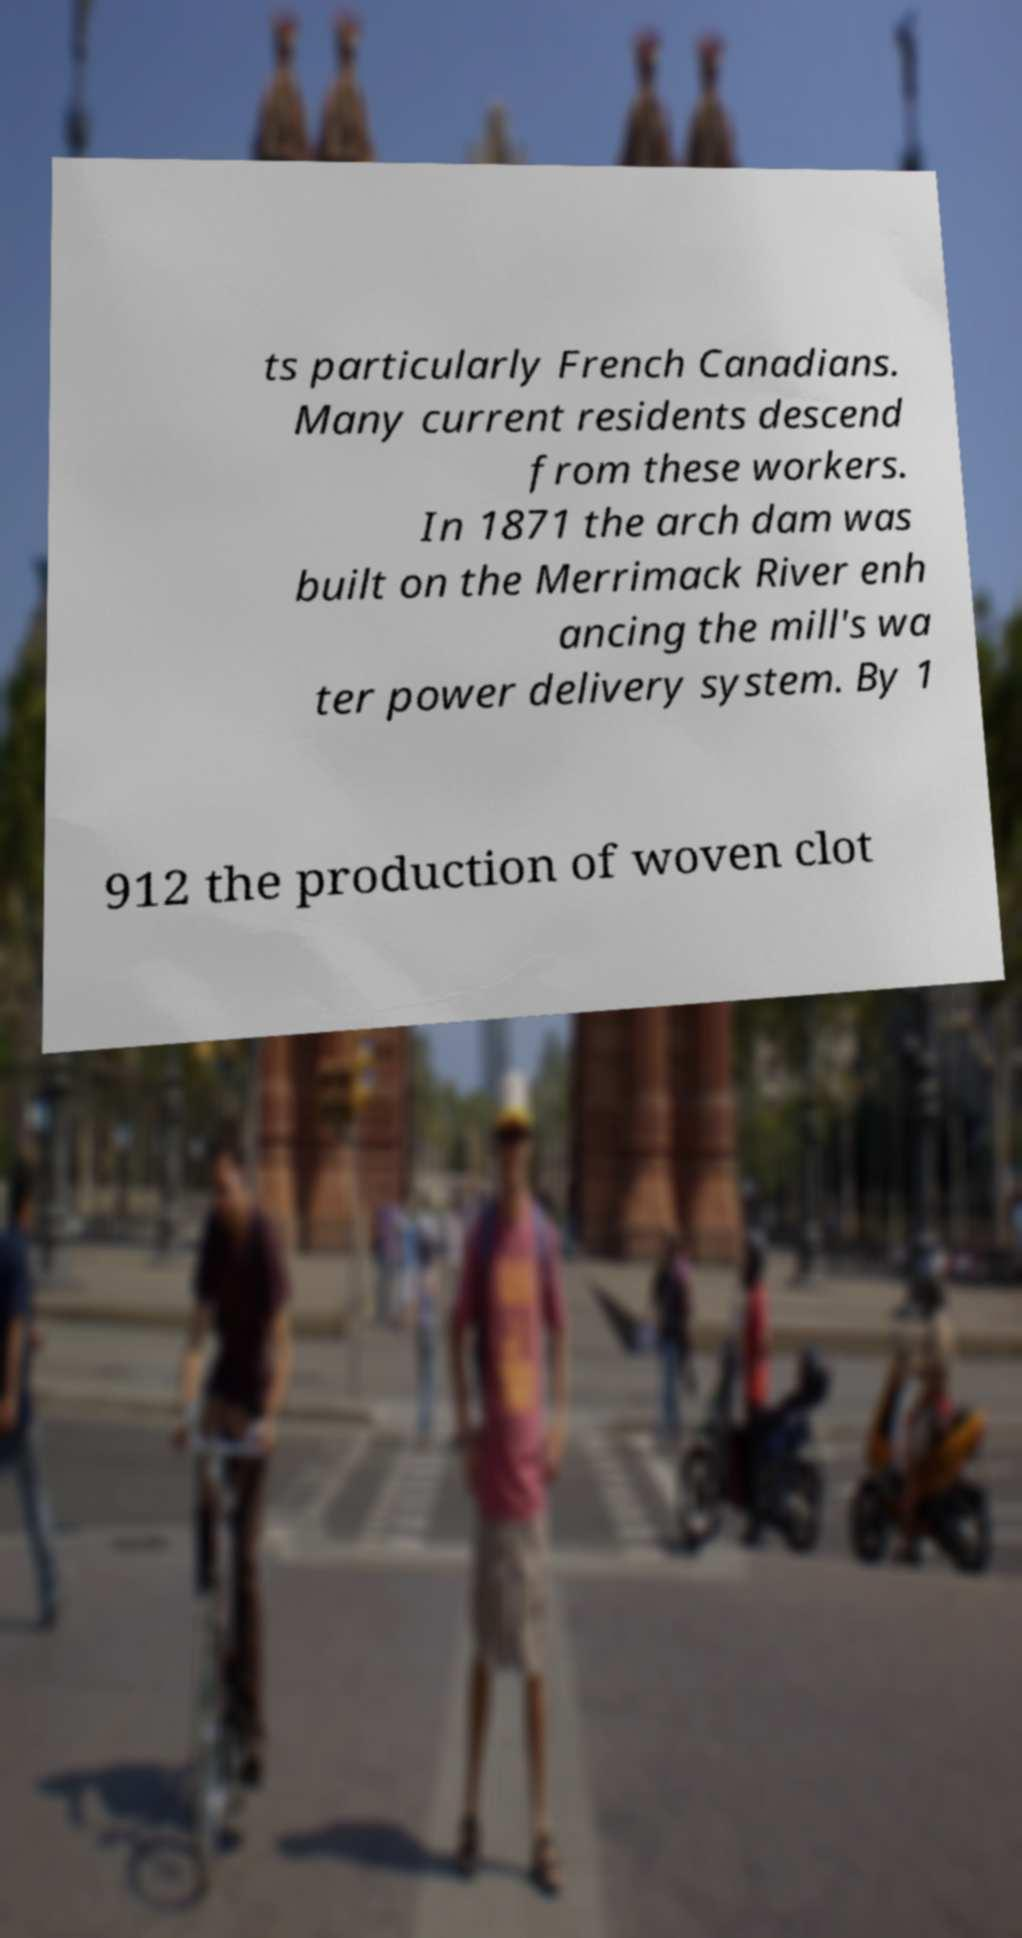Please read and relay the text visible in this image. What does it say? ts particularly French Canadians. Many current residents descend from these workers. In 1871 the arch dam was built on the Merrimack River enh ancing the mill's wa ter power delivery system. By 1 912 the production of woven clot 